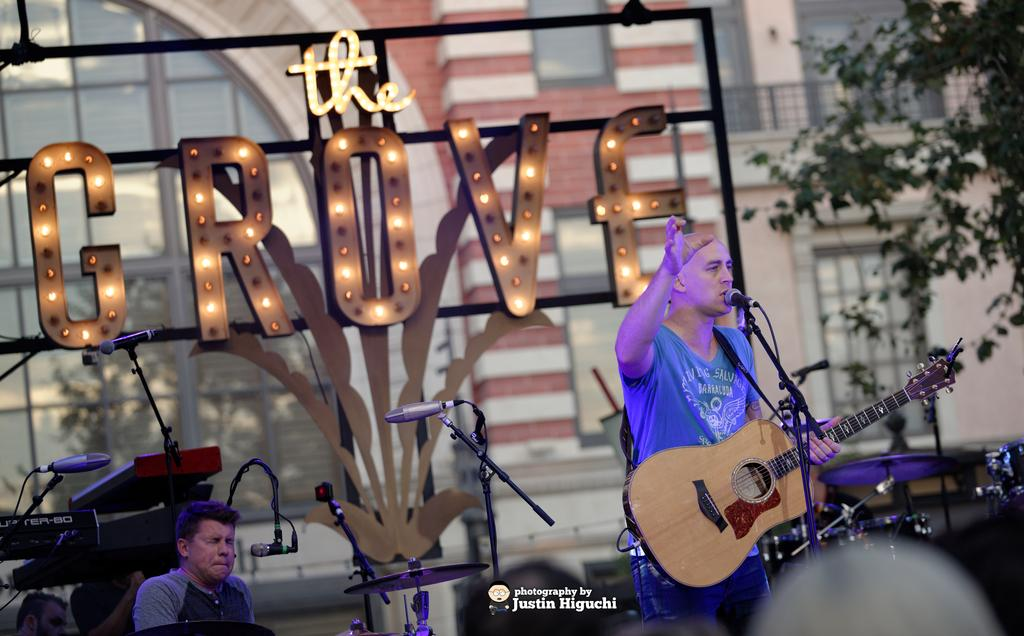How many people are in the image? There are two people in the image. What is one person holding in the image? One person is holding a guitar. What equipment is present for amplifying sound in the image? There is a microphone and a microphone stand in the image. What can be seen in the background of the image? There is a building and a tree in the background of the image. How many cents are visible on the guitar in the image? There are no cents visible on the guitar in the image. What type of comfort can be seen in the image? There is no reference to comfort in the image; it features two people, a guitar, a microphone, a microphone stand, a building, and a tree. 